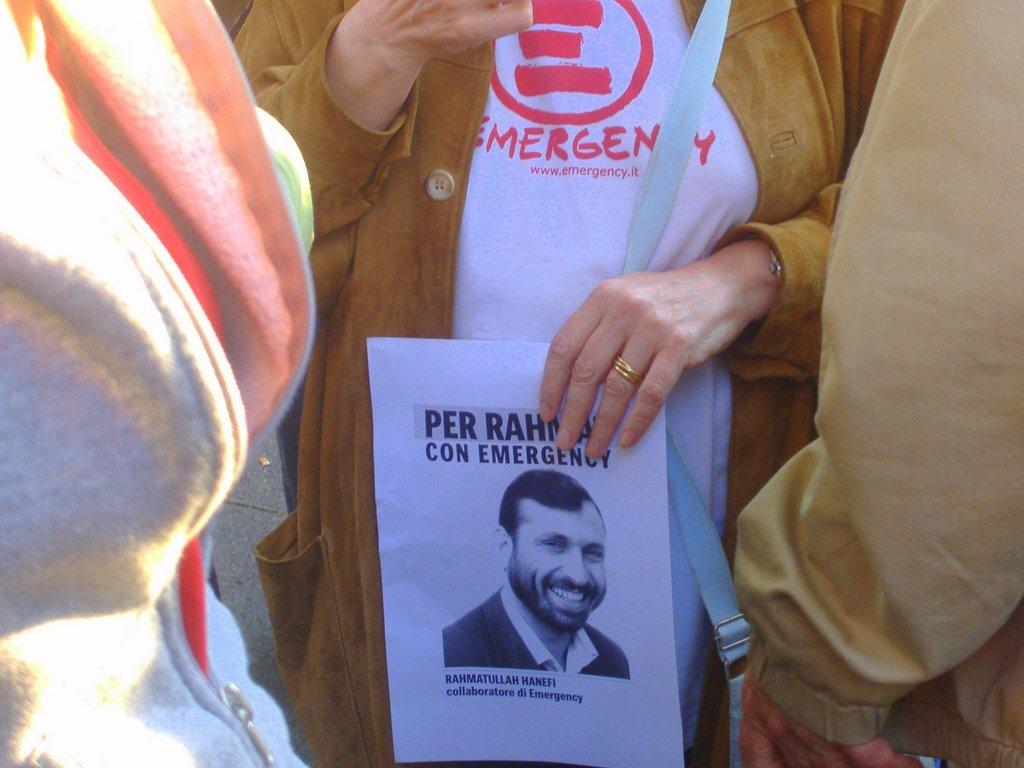What is the person in the image doing? The person in the image is holding a paper. What is on the paper that the person is holding? There is an image of a man on the paper. How many boys are blowing bubbles in the image? There are no boys or bubbles present in the image. 